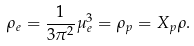Convert formula to latex. <formula><loc_0><loc_0><loc_500><loc_500>\rho _ { e } = \frac { 1 } { 3 \pi ^ { 2 } } \mu _ { e } ^ { 3 } = \rho _ { p } = X _ { p } \rho .</formula> 